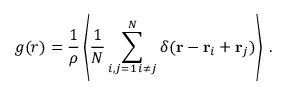Convert formula to latex. <formula><loc_0><loc_0><loc_500><loc_500>g ( r ) = \frac { 1 } { \rho } \left \langle \frac { 1 } { N } \sum _ { \substack { i , j = 1 \, i \neq j } } ^ { N } \delta ( { r } - { r } _ { i } + { r } _ { j } ) \right \rangle \, .</formula> 